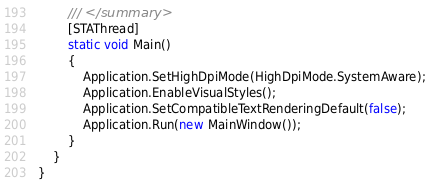<code> <loc_0><loc_0><loc_500><loc_500><_C#_>        /// </summary>
        [STAThread]
        static void Main()
        {
            Application.SetHighDpiMode(HighDpiMode.SystemAware);
            Application.EnableVisualStyles();
            Application.SetCompatibleTextRenderingDefault(false);
            Application.Run(new MainWindow());
        }
    }
}
</code> 